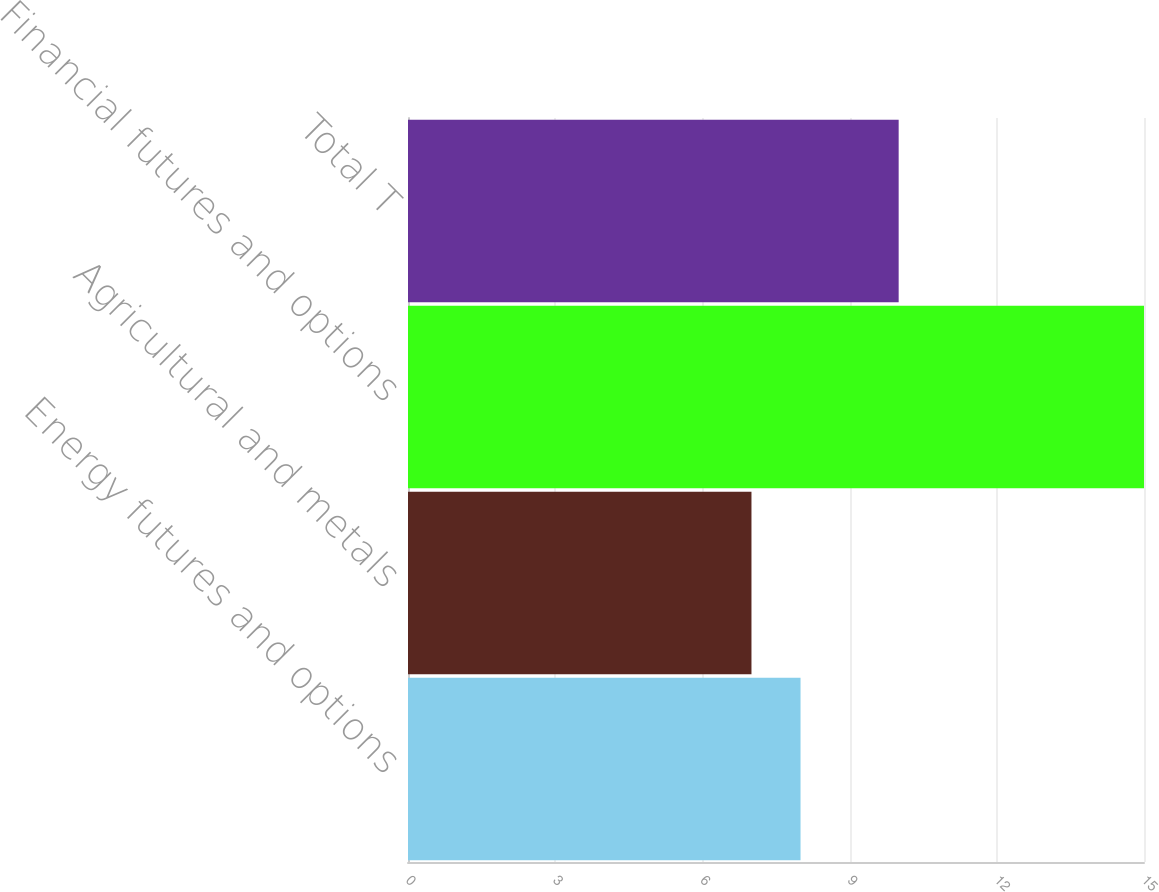<chart> <loc_0><loc_0><loc_500><loc_500><bar_chart><fcel>Energy futures and options<fcel>Agricultural and metals<fcel>Financial futures and options<fcel>Total T<nl><fcel>8<fcel>7<fcel>15<fcel>10<nl></chart> 